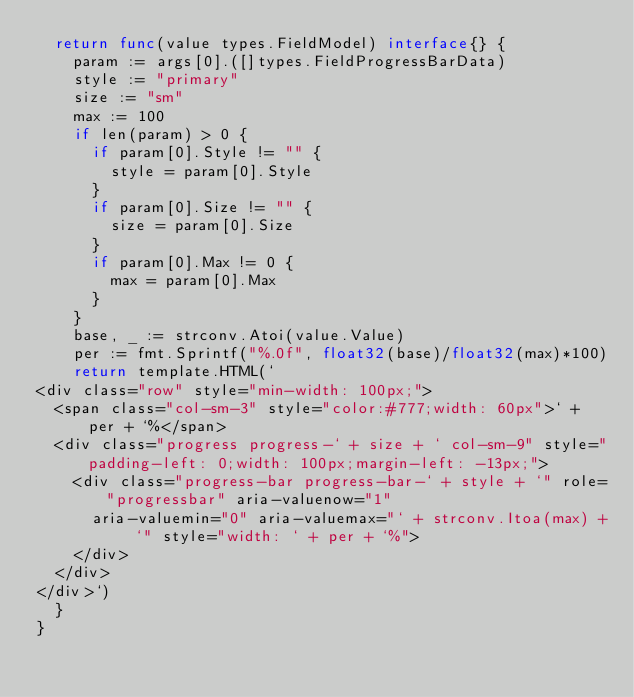<code> <loc_0><loc_0><loc_500><loc_500><_Go_>	return func(value types.FieldModel) interface{} {
		param := args[0].([]types.FieldProgressBarData)
		style := "primary"
		size := "sm"
		max := 100
		if len(param) > 0 {
			if param[0].Style != "" {
				style = param[0].Style
			}
			if param[0].Size != "" {
				size = param[0].Size
			}
			if param[0].Max != 0 {
				max = param[0].Max
			}
		}
		base, _ := strconv.Atoi(value.Value)
		per := fmt.Sprintf("%.0f", float32(base)/float32(max)*100)
		return template.HTML(`
<div class="row" style="min-width: 100px;">
	<span class="col-sm-3" style="color:#777;width: 60px">` + per + `%</span>
	<div class="progress progress-` + size + ` col-sm-9" style="padding-left: 0;width: 100px;margin-left: -13px;">
		<div class="progress-bar progress-bar-` + style + `" role="progressbar" aria-valuenow="1" 
			aria-valuemin="0" aria-valuemax="` + strconv.Itoa(max) + `" style="width: ` + per + `%">
		</div>
	</div>
</div>`)
	}
}
</code> 